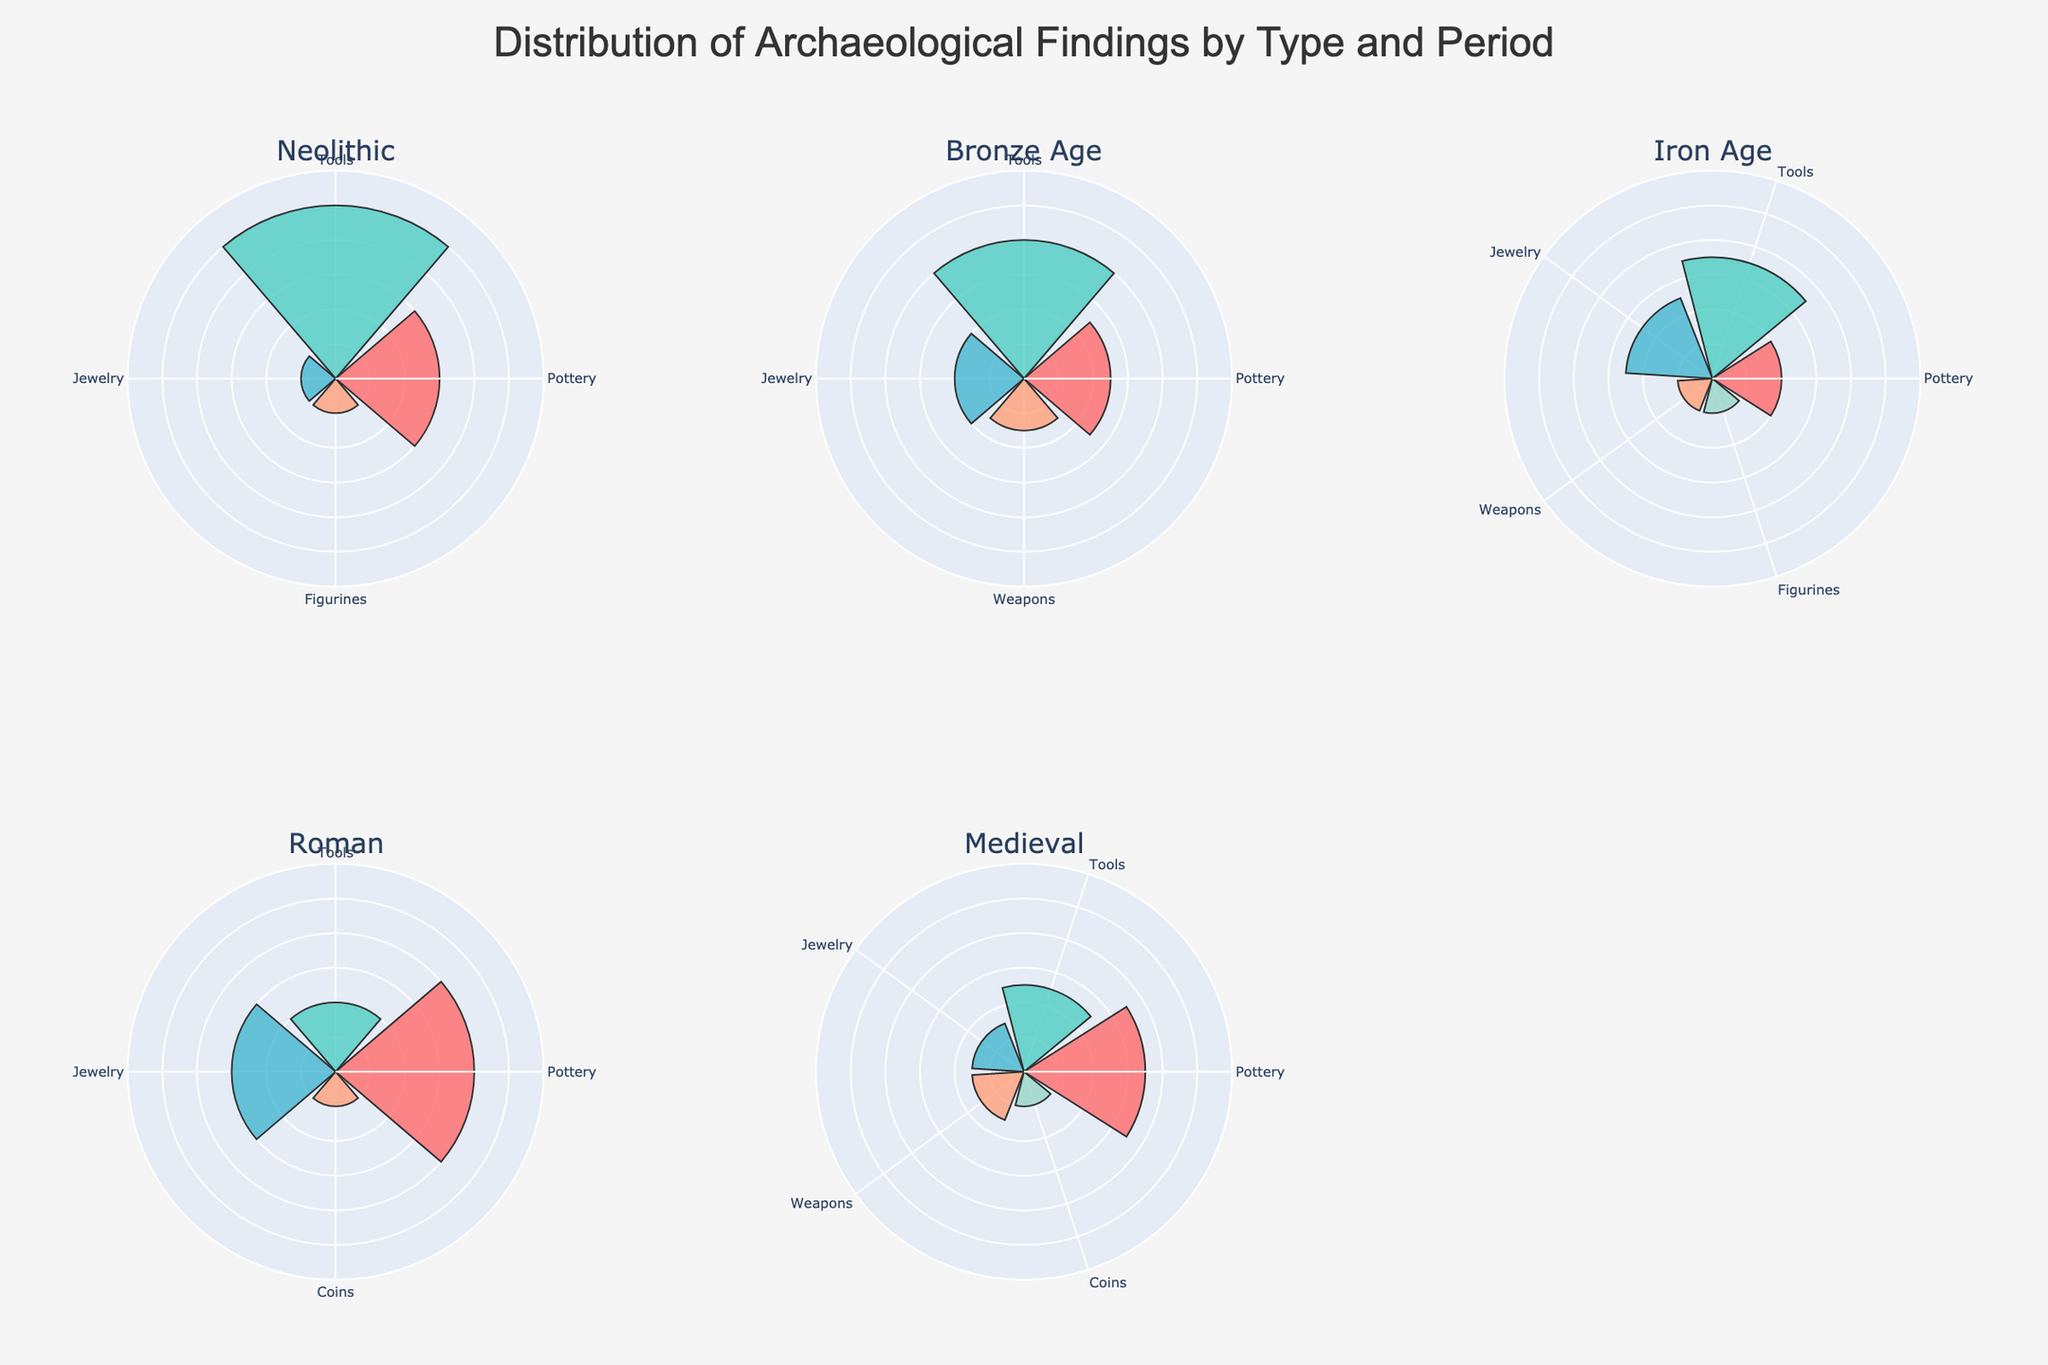What is the title of the figure? The title is positioned at the top center of the figure. By looking at it, we can directly read the text.
Answer: Distribution of Archaeological Findings by Type and Period Which historical period has the highest percentage of Pottery findings? By examining each rose chart, we find the segment corresponding to Pottery and compare their sizes across all historical periods.
Answer: Roman What percentage of Tools findings are there in the Neolithic period? Identify the Neolithic rose chart, look for the segment labeled as Tools, and read off its percentage.
Answer: 50% Sum the percentages of Jewelry findings across all historical periods. Locate each Jewelry segment in the four rose charts, sum their percentages: 10 (Neolithic) + 20 (Bronze Age) + 25 (Iron Age) + 30 (Roman) + 15 (Medieval) = 100.
Answer: 100 Which period has the smallest percentage of Weapons findings, and what is that percentage? Check each period’s rose chart for the Weapons segment, noting the percentages, and identify the smallest one.
Answer: Iron Age, 10% Compare the percentage of Coins findings between Roman and Medieval periods. Which one is greater and by how much? Look at the Roman and Medieval rose charts, locate the Coins segment in both, and subtract their percentages: 10 (Roman) - 10 (Medieval) = 0.
Answer: They are equal What is the average percentage of all types in the Bronze Age period? Sum the percentages of all segments in the Bronze Age chart and divide by the number of segments: (25 + 40 + 20 + 15) / 4 = 25
Answer: 25% Which type of finding is not present in the Roman period? Examine the Roman rose chart and list all finding types. Identify any types present in other periods but missing in the Roman period.
Answer: Figurines In which period do Tools findings appear to have the lowest percentage, and what is that percentage? Compare the Tools segments across all periods, noting the percentages and find the smallest one.
Answer: Roman, 20% How does the distribution of findings in the Medieval period compare to the Neolithic period regarding Pottery and Tools? Compare the sizes of the Pottery and Tools segments in the Medieval and Neolithic rose charts: Pottery (Neolithic 30%, Medieval 35%), Tools (Neolithic 50%, Medieval 25%).
Answer: Pottery is higher in Medieval; Tools are higher in Neolithic 